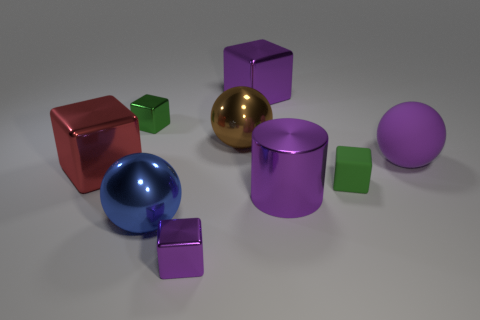What could be the possible use for these objects? These objects resemble geometric shapes often used for educational purposes, demonstrating principles of geometry, volume, and spatial relations or in computer graphics for rendering and shading tests. 